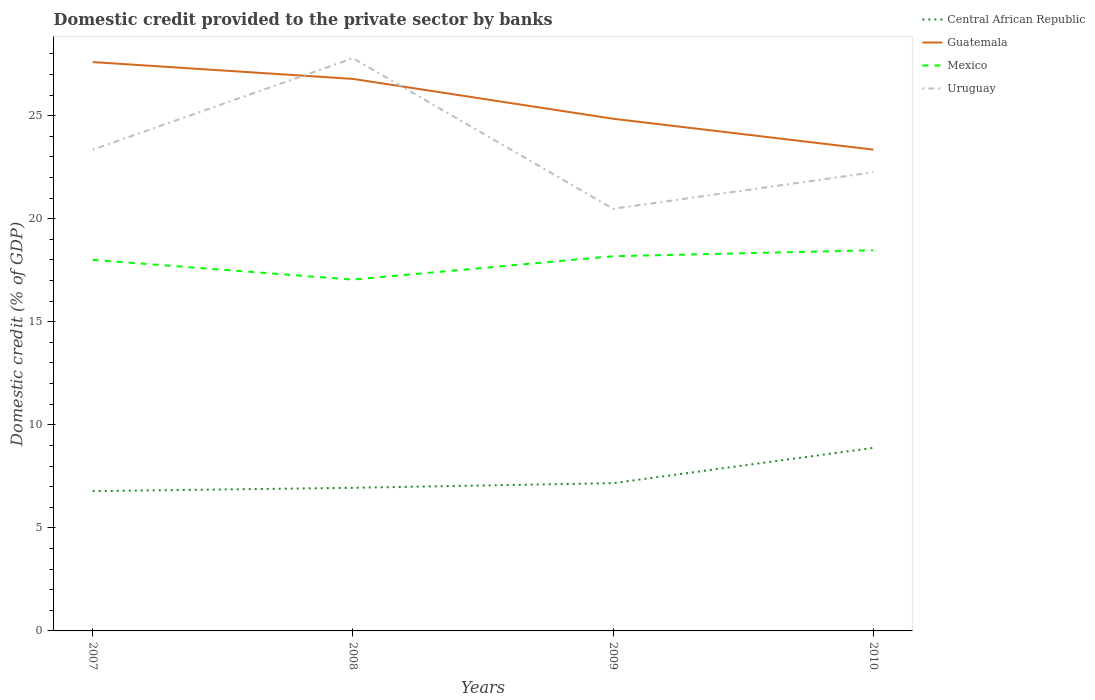Does the line corresponding to Mexico intersect with the line corresponding to Central African Republic?
Your answer should be very brief. No. Across all years, what is the maximum domestic credit provided to the private sector by banks in Guatemala?
Provide a succinct answer. 23.35. In which year was the domestic credit provided to the private sector by banks in Central African Republic maximum?
Give a very brief answer. 2007. What is the total domestic credit provided to the private sector by banks in Mexico in the graph?
Provide a short and direct response. -1.42. What is the difference between the highest and the second highest domestic credit provided to the private sector by banks in Central African Republic?
Make the answer very short. 2.1. What is the difference between the highest and the lowest domestic credit provided to the private sector by banks in Guatemala?
Provide a succinct answer. 2. How many lines are there?
Ensure brevity in your answer.  4. How many years are there in the graph?
Your answer should be compact. 4. What is the difference between two consecutive major ticks on the Y-axis?
Your answer should be very brief. 5. Are the values on the major ticks of Y-axis written in scientific E-notation?
Your answer should be compact. No. Where does the legend appear in the graph?
Keep it short and to the point. Top right. How are the legend labels stacked?
Provide a short and direct response. Vertical. What is the title of the graph?
Offer a very short reply. Domestic credit provided to the private sector by banks. Does "Guinea-Bissau" appear as one of the legend labels in the graph?
Give a very brief answer. No. What is the label or title of the Y-axis?
Keep it short and to the point. Domestic credit (% of GDP). What is the Domestic credit (% of GDP) of Central African Republic in 2007?
Give a very brief answer. 6.78. What is the Domestic credit (% of GDP) in Guatemala in 2007?
Your answer should be compact. 27.6. What is the Domestic credit (% of GDP) in Mexico in 2007?
Make the answer very short. 18. What is the Domestic credit (% of GDP) in Uruguay in 2007?
Provide a short and direct response. 23.35. What is the Domestic credit (% of GDP) in Central African Republic in 2008?
Ensure brevity in your answer.  6.94. What is the Domestic credit (% of GDP) in Guatemala in 2008?
Make the answer very short. 26.78. What is the Domestic credit (% of GDP) in Mexico in 2008?
Offer a terse response. 17.05. What is the Domestic credit (% of GDP) of Uruguay in 2008?
Your answer should be very brief. 27.79. What is the Domestic credit (% of GDP) of Central African Republic in 2009?
Offer a very short reply. 7.17. What is the Domestic credit (% of GDP) in Guatemala in 2009?
Your answer should be compact. 24.85. What is the Domestic credit (% of GDP) in Mexico in 2009?
Your answer should be very brief. 18.18. What is the Domestic credit (% of GDP) of Uruguay in 2009?
Your answer should be compact. 20.48. What is the Domestic credit (% of GDP) of Central African Republic in 2010?
Your answer should be compact. 8.88. What is the Domestic credit (% of GDP) in Guatemala in 2010?
Your answer should be compact. 23.35. What is the Domestic credit (% of GDP) in Mexico in 2010?
Ensure brevity in your answer.  18.47. What is the Domestic credit (% of GDP) of Uruguay in 2010?
Make the answer very short. 22.25. Across all years, what is the maximum Domestic credit (% of GDP) in Central African Republic?
Offer a terse response. 8.88. Across all years, what is the maximum Domestic credit (% of GDP) of Guatemala?
Your response must be concise. 27.6. Across all years, what is the maximum Domestic credit (% of GDP) in Mexico?
Your response must be concise. 18.47. Across all years, what is the maximum Domestic credit (% of GDP) in Uruguay?
Ensure brevity in your answer.  27.79. Across all years, what is the minimum Domestic credit (% of GDP) of Central African Republic?
Provide a short and direct response. 6.78. Across all years, what is the minimum Domestic credit (% of GDP) in Guatemala?
Make the answer very short. 23.35. Across all years, what is the minimum Domestic credit (% of GDP) of Mexico?
Provide a succinct answer. 17.05. Across all years, what is the minimum Domestic credit (% of GDP) of Uruguay?
Make the answer very short. 20.48. What is the total Domestic credit (% of GDP) in Central African Republic in the graph?
Provide a short and direct response. 29.78. What is the total Domestic credit (% of GDP) in Guatemala in the graph?
Your answer should be compact. 102.59. What is the total Domestic credit (% of GDP) of Mexico in the graph?
Keep it short and to the point. 71.7. What is the total Domestic credit (% of GDP) of Uruguay in the graph?
Provide a short and direct response. 93.87. What is the difference between the Domestic credit (% of GDP) of Central African Republic in 2007 and that in 2008?
Ensure brevity in your answer.  -0.16. What is the difference between the Domestic credit (% of GDP) in Guatemala in 2007 and that in 2008?
Provide a short and direct response. 0.82. What is the difference between the Domestic credit (% of GDP) of Mexico in 2007 and that in 2008?
Your answer should be compact. 0.96. What is the difference between the Domestic credit (% of GDP) in Uruguay in 2007 and that in 2008?
Ensure brevity in your answer.  -4.44. What is the difference between the Domestic credit (% of GDP) in Central African Republic in 2007 and that in 2009?
Your response must be concise. -0.39. What is the difference between the Domestic credit (% of GDP) in Guatemala in 2007 and that in 2009?
Your answer should be compact. 2.75. What is the difference between the Domestic credit (% of GDP) in Mexico in 2007 and that in 2009?
Your answer should be very brief. -0.18. What is the difference between the Domestic credit (% of GDP) of Uruguay in 2007 and that in 2009?
Keep it short and to the point. 2.87. What is the difference between the Domestic credit (% of GDP) in Central African Republic in 2007 and that in 2010?
Provide a succinct answer. -2.1. What is the difference between the Domestic credit (% of GDP) of Guatemala in 2007 and that in 2010?
Your response must be concise. 4.25. What is the difference between the Domestic credit (% of GDP) of Mexico in 2007 and that in 2010?
Provide a succinct answer. -0.47. What is the difference between the Domestic credit (% of GDP) in Uruguay in 2007 and that in 2010?
Provide a succinct answer. 1.1. What is the difference between the Domestic credit (% of GDP) of Central African Republic in 2008 and that in 2009?
Your response must be concise. -0.23. What is the difference between the Domestic credit (% of GDP) in Guatemala in 2008 and that in 2009?
Ensure brevity in your answer.  1.93. What is the difference between the Domestic credit (% of GDP) of Mexico in 2008 and that in 2009?
Provide a short and direct response. -1.13. What is the difference between the Domestic credit (% of GDP) of Uruguay in 2008 and that in 2009?
Your answer should be very brief. 7.31. What is the difference between the Domestic credit (% of GDP) in Central African Republic in 2008 and that in 2010?
Provide a succinct answer. -1.94. What is the difference between the Domestic credit (% of GDP) of Guatemala in 2008 and that in 2010?
Keep it short and to the point. 3.43. What is the difference between the Domestic credit (% of GDP) of Mexico in 2008 and that in 2010?
Make the answer very short. -1.42. What is the difference between the Domestic credit (% of GDP) in Uruguay in 2008 and that in 2010?
Provide a succinct answer. 5.53. What is the difference between the Domestic credit (% of GDP) in Central African Republic in 2009 and that in 2010?
Offer a very short reply. -1.71. What is the difference between the Domestic credit (% of GDP) in Guatemala in 2009 and that in 2010?
Offer a terse response. 1.5. What is the difference between the Domestic credit (% of GDP) of Mexico in 2009 and that in 2010?
Offer a very short reply. -0.29. What is the difference between the Domestic credit (% of GDP) of Uruguay in 2009 and that in 2010?
Give a very brief answer. -1.77. What is the difference between the Domestic credit (% of GDP) in Central African Republic in 2007 and the Domestic credit (% of GDP) in Guatemala in 2008?
Offer a terse response. -20. What is the difference between the Domestic credit (% of GDP) of Central African Republic in 2007 and the Domestic credit (% of GDP) of Mexico in 2008?
Offer a very short reply. -10.26. What is the difference between the Domestic credit (% of GDP) in Central African Republic in 2007 and the Domestic credit (% of GDP) in Uruguay in 2008?
Make the answer very short. -21. What is the difference between the Domestic credit (% of GDP) in Guatemala in 2007 and the Domestic credit (% of GDP) in Mexico in 2008?
Your answer should be compact. 10.56. What is the difference between the Domestic credit (% of GDP) in Guatemala in 2007 and the Domestic credit (% of GDP) in Uruguay in 2008?
Keep it short and to the point. -0.19. What is the difference between the Domestic credit (% of GDP) of Mexico in 2007 and the Domestic credit (% of GDP) of Uruguay in 2008?
Make the answer very short. -9.79. What is the difference between the Domestic credit (% of GDP) of Central African Republic in 2007 and the Domestic credit (% of GDP) of Guatemala in 2009?
Offer a terse response. -18.07. What is the difference between the Domestic credit (% of GDP) in Central African Republic in 2007 and the Domestic credit (% of GDP) in Mexico in 2009?
Offer a terse response. -11.4. What is the difference between the Domestic credit (% of GDP) in Central African Republic in 2007 and the Domestic credit (% of GDP) in Uruguay in 2009?
Give a very brief answer. -13.7. What is the difference between the Domestic credit (% of GDP) in Guatemala in 2007 and the Domestic credit (% of GDP) in Mexico in 2009?
Your answer should be very brief. 9.42. What is the difference between the Domestic credit (% of GDP) of Guatemala in 2007 and the Domestic credit (% of GDP) of Uruguay in 2009?
Your answer should be very brief. 7.12. What is the difference between the Domestic credit (% of GDP) in Mexico in 2007 and the Domestic credit (% of GDP) in Uruguay in 2009?
Keep it short and to the point. -2.48. What is the difference between the Domestic credit (% of GDP) of Central African Republic in 2007 and the Domestic credit (% of GDP) of Guatemala in 2010?
Provide a succinct answer. -16.57. What is the difference between the Domestic credit (% of GDP) in Central African Republic in 2007 and the Domestic credit (% of GDP) in Mexico in 2010?
Provide a short and direct response. -11.69. What is the difference between the Domestic credit (% of GDP) of Central African Republic in 2007 and the Domestic credit (% of GDP) of Uruguay in 2010?
Keep it short and to the point. -15.47. What is the difference between the Domestic credit (% of GDP) in Guatemala in 2007 and the Domestic credit (% of GDP) in Mexico in 2010?
Offer a terse response. 9.13. What is the difference between the Domestic credit (% of GDP) in Guatemala in 2007 and the Domestic credit (% of GDP) in Uruguay in 2010?
Offer a very short reply. 5.35. What is the difference between the Domestic credit (% of GDP) in Mexico in 2007 and the Domestic credit (% of GDP) in Uruguay in 2010?
Give a very brief answer. -4.25. What is the difference between the Domestic credit (% of GDP) of Central African Republic in 2008 and the Domestic credit (% of GDP) of Guatemala in 2009?
Give a very brief answer. -17.91. What is the difference between the Domestic credit (% of GDP) of Central African Republic in 2008 and the Domestic credit (% of GDP) of Mexico in 2009?
Keep it short and to the point. -11.24. What is the difference between the Domestic credit (% of GDP) of Central African Republic in 2008 and the Domestic credit (% of GDP) of Uruguay in 2009?
Your response must be concise. -13.54. What is the difference between the Domestic credit (% of GDP) of Guatemala in 2008 and the Domestic credit (% of GDP) of Mexico in 2009?
Provide a succinct answer. 8.6. What is the difference between the Domestic credit (% of GDP) in Guatemala in 2008 and the Domestic credit (% of GDP) in Uruguay in 2009?
Make the answer very short. 6.3. What is the difference between the Domestic credit (% of GDP) in Mexico in 2008 and the Domestic credit (% of GDP) in Uruguay in 2009?
Your answer should be very brief. -3.44. What is the difference between the Domestic credit (% of GDP) in Central African Republic in 2008 and the Domestic credit (% of GDP) in Guatemala in 2010?
Ensure brevity in your answer.  -16.41. What is the difference between the Domestic credit (% of GDP) of Central African Republic in 2008 and the Domestic credit (% of GDP) of Mexico in 2010?
Your response must be concise. -11.53. What is the difference between the Domestic credit (% of GDP) of Central African Republic in 2008 and the Domestic credit (% of GDP) of Uruguay in 2010?
Make the answer very short. -15.31. What is the difference between the Domestic credit (% of GDP) of Guatemala in 2008 and the Domestic credit (% of GDP) of Mexico in 2010?
Give a very brief answer. 8.31. What is the difference between the Domestic credit (% of GDP) of Guatemala in 2008 and the Domestic credit (% of GDP) of Uruguay in 2010?
Your response must be concise. 4.53. What is the difference between the Domestic credit (% of GDP) in Mexico in 2008 and the Domestic credit (% of GDP) in Uruguay in 2010?
Make the answer very short. -5.21. What is the difference between the Domestic credit (% of GDP) in Central African Republic in 2009 and the Domestic credit (% of GDP) in Guatemala in 2010?
Your answer should be very brief. -16.18. What is the difference between the Domestic credit (% of GDP) in Central African Republic in 2009 and the Domestic credit (% of GDP) in Mexico in 2010?
Your response must be concise. -11.3. What is the difference between the Domestic credit (% of GDP) in Central African Republic in 2009 and the Domestic credit (% of GDP) in Uruguay in 2010?
Make the answer very short. -15.08. What is the difference between the Domestic credit (% of GDP) of Guatemala in 2009 and the Domestic credit (% of GDP) of Mexico in 2010?
Provide a succinct answer. 6.38. What is the difference between the Domestic credit (% of GDP) of Guatemala in 2009 and the Domestic credit (% of GDP) of Uruguay in 2010?
Make the answer very short. 2.6. What is the difference between the Domestic credit (% of GDP) of Mexico in 2009 and the Domestic credit (% of GDP) of Uruguay in 2010?
Make the answer very short. -4.07. What is the average Domestic credit (% of GDP) of Central African Republic per year?
Give a very brief answer. 7.44. What is the average Domestic credit (% of GDP) of Guatemala per year?
Offer a terse response. 25.65. What is the average Domestic credit (% of GDP) in Mexico per year?
Offer a very short reply. 17.92. What is the average Domestic credit (% of GDP) in Uruguay per year?
Make the answer very short. 23.47. In the year 2007, what is the difference between the Domestic credit (% of GDP) in Central African Republic and Domestic credit (% of GDP) in Guatemala?
Keep it short and to the point. -20.82. In the year 2007, what is the difference between the Domestic credit (% of GDP) of Central African Republic and Domestic credit (% of GDP) of Mexico?
Your answer should be compact. -11.22. In the year 2007, what is the difference between the Domestic credit (% of GDP) in Central African Republic and Domestic credit (% of GDP) in Uruguay?
Offer a very short reply. -16.57. In the year 2007, what is the difference between the Domestic credit (% of GDP) in Guatemala and Domestic credit (% of GDP) in Mexico?
Your response must be concise. 9.6. In the year 2007, what is the difference between the Domestic credit (% of GDP) in Guatemala and Domestic credit (% of GDP) in Uruguay?
Provide a succinct answer. 4.25. In the year 2007, what is the difference between the Domestic credit (% of GDP) of Mexico and Domestic credit (% of GDP) of Uruguay?
Your answer should be very brief. -5.35. In the year 2008, what is the difference between the Domestic credit (% of GDP) in Central African Republic and Domestic credit (% of GDP) in Guatemala?
Your response must be concise. -19.84. In the year 2008, what is the difference between the Domestic credit (% of GDP) of Central African Republic and Domestic credit (% of GDP) of Mexico?
Offer a very short reply. -10.1. In the year 2008, what is the difference between the Domestic credit (% of GDP) in Central African Republic and Domestic credit (% of GDP) in Uruguay?
Your response must be concise. -20.84. In the year 2008, what is the difference between the Domestic credit (% of GDP) in Guatemala and Domestic credit (% of GDP) in Mexico?
Provide a succinct answer. 9.74. In the year 2008, what is the difference between the Domestic credit (% of GDP) in Guatemala and Domestic credit (% of GDP) in Uruguay?
Offer a terse response. -1. In the year 2008, what is the difference between the Domestic credit (% of GDP) of Mexico and Domestic credit (% of GDP) of Uruguay?
Give a very brief answer. -10.74. In the year 2009, what is the difference between the Domestic credit (% of GDP) of Central African Republic and Domestic credit (% of GDP) of Guatemala?
Your answer should be very brief. -17.68. In the year 2009, what is the difference between the Domestic credit (% of GDP) of Central African Republic and Domestic credit (% of GDP) of Mexico?
Your answer should be compact. -11.01. In the year 2009, what is the difference between the Domestic credit (% of GDP) in Central African Republic and Domestic credit (% of GDP) in Uruguay?
Ensure brevity in your answer.  -13.31. In the year 2009, what is the difference between the Domestic credit (% of GDP) in Guatemala and Domestic credit (% of GDP) in Mexico?
Your response must be concise. 6.67. In the year 2009, what is the difference between the Domestic credit (% of GDP) in Guatemala and Domestic credit (% of GDP) in Uruguay?
Your answer should be very brief. 4.37. In the year 2009, what is the difference between the Domestic credit (% of GDP) in Mexico and Domestic credit (% of GDP) in Uruguay?
Offer a terse response. -2.3. In the year 2010, what is the difference between the Domestic credit (% of GDP) of Central African Republic and Domestic credit (% of GDP) of Guatemala?
Your response must be concise. -14.47. In the year 2010, what is the difference between the Domestic credit (% of GDP) of Central African Republic and Domestic credit (% of GDP) of Mexico?
Your answer should be compact. -9.59. In the year 2010, what is the difference between the Domestic credit (% of GDP) in Central African Republic and Domestic credit (% of GDP) in Uruguay?
Offer a very short reply. -13.37. In the year 2010, what is the difference between the Domestic credit (% of GDP) of Guatemala and Domestic credit (% of GDP) of Mexico?
Offer a terse response. 4.88. In the year 2010, what is the difference between the Domestic credit (% of GDP) in Guatemala and Domestic credit (% of GDP) in Uruguay?
Your response must be concise. 1.1. In the year 2010, what is the difference between the Domestic credit (% of GDP) of Mexico and Domestic credit (% of GDP) of Uruguay?
Provide a short and direct response. -3.78. What is the ratio of the Domestic credit (% of GDP) of Central African Republic in 2007 to that in 2008?
Ensure brevity in your answer.  0.98. What is the ratio of the Domestic credit (% of GDP) of Guatemala in 2007 to that in 2008?
Give a very brief answer. 1.03. What is the ratio of the Domestic credit (% of GDP) of Mexico in 2007 to that in 2008?
Provide a succinct answer. 1.06. What is the ratio of the Domestic credit (% of GDP) of Uruguay in 2007 to that in 2008?
Your answer should be very brief. 0.84. What is the ratio of the Domestic credit (% of GDP) of Central African Republic in 2007 to that in 2009?
Offer a terse response. 0.95. What is the ratio of the Domestic credit (% of GDP) of Guatemala in 2007 to that in 2009?
Your response must be concise. 1.11. What is the ratio of the Domestic credit (% of GDP) of Mexico in 2007 to that in 2009?
Offer a terse response. 0.99. What is the ratio of the Domestic credit (% of GDP) in Uruguay in 2007 to that in 2009?
Offer a terse response. 1.14. What is the ratio of the Domestic credit (% of GDP) in Central African Republic in 2007 to that in 2010?
Your answer should be very brief. 0.76. What is the ratio of the Domestic credit (% of GDP) of Guatemala in 2007 to that in 2010?
Ensure brevity in your answer.  1.18. What is the ratio of the Domestic credit (% of GDP) of Mexico in 2007 to that in 2010?
Your answer should be very brief. 0.97. What is the ratio of the Domestic credit (% of GDP) in Uruguay in 2007 to that in 2010?
Your answer should be very brief. 1.05. What is the ratio of the Domestic credit (% of GDP) in Central African Republic in 2008 to that in 2009?
Your answer should be compact. 0.97. What is the ratio of the Domestic credit (% of GDP) of Guatemala in 2008 to that in 2009?
Offer a very short reply. 1.08. What is the ratio of the Domestic credit (% of GDP) of Mexico in 2008 to that in 2009?
Your answer should be very brief. 0.94. What is the ratio of the Domestic credit (% of GDP) of Uruguay in 2008 to that in 2009?
Provide a succinct answer. 1.36. What is the ratio of the Domestic credit (% of GDP) in Central African Republic in 2008 to that in 2010?
Provide a short and direct response. 0.78. What is the ratio of the Domestic credit (% of GDP) of Guatemala in 2008 to that in 2010?
Your response must be concise. 1.15. What is the ratio of the Domestic credit (% of GDP) in Mexico in 2008 to that in 2010?
Provide a succinct answer. 0.92. What is the ratio of the Domestic credit (% of GDP) in Uruguay in 2008 to that in 2010?
Offer a very short reply. 1.25. What is the ratio of the Domestic credit (% of GDP) in Central African Republic in 2009 to that in 2010?
Give a very brief answer. 0.81. What is the ratio of the Domestic credit (% of GDP) of Guatemala in 2009 to that in 2010?
Offer a very short reply. 1.06. What is the ratio of the Domestic credit (% of GDP) in Mexico in 2009 to that in 2010?
Ensure brevity in your answer.  0.98. What is the ratio of the Domestic credit (% of GDP) in Uruguay in 2009 to that in 2010?
Provide a succinct answer. 0.92. What is the difference between the highest and the second highest Domestic credit (% of GDP) of Central African Republic?
Your response must be concise. 1.71. What is the difference between the highest and the second highest Domestic credit (% of GDP) of Guatemala?
Provide a succinct answer. 0.82. What is the difference between the highest and the second highest Domestic credit (% of GDP) in Mexico?
Ensure brevity in your answer.  0.29. What is the difference between the highest and the second highest Domestic credit (% of GDP) of Uruguay?
Give a very brief answer. 4.44. What is the difference between the highest and the lowest Domestic credit (% of GDP) of Central African Republic?
Ensure brevity in your answer.  2.1. What is the difference between the highest and the lowest Domestic credit (% of GDP) of Guatemala?
Your response must be concise. 4.25. What is the difference between the highest and the lowest Domestic credit (% of GDP) in Mexico?
Ensure brevity in your answer.  1.42. What is the difference between the highest and the lowest Domestic credit (% of GDP) in Uruguay?
Keep it short and to the point. 7.31. 